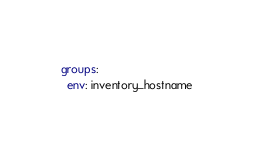<code> <loc_0><loc_0><loc_500><loc_500><_YAML_>groups:
  env: inventory_hostname
</code> 